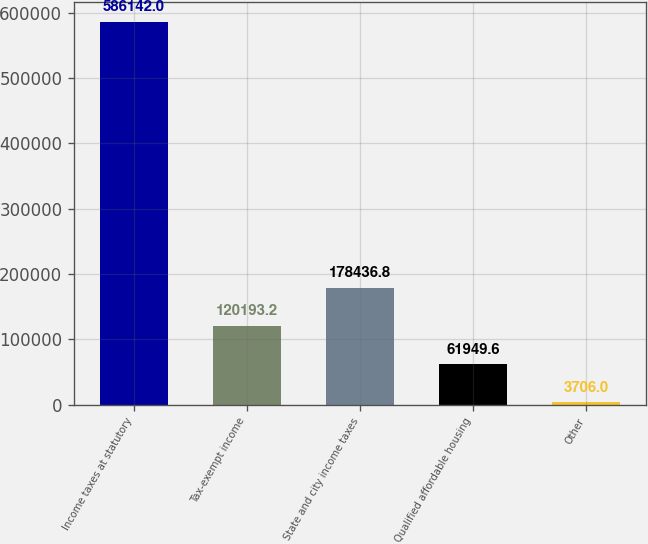<chart> <loc_0><loc_0><loc_500><loc_500><bar_chart><fcel>Income taxes at statutory<fcel>Tax-exempt income<fcel>State and city income taxes<fcel>Qualified affordable housing<fcel>Other<nl><fcel>586142<fcel>120193<fcel>178437<fcel>61949.6<fcel>3706<nl></chart> 